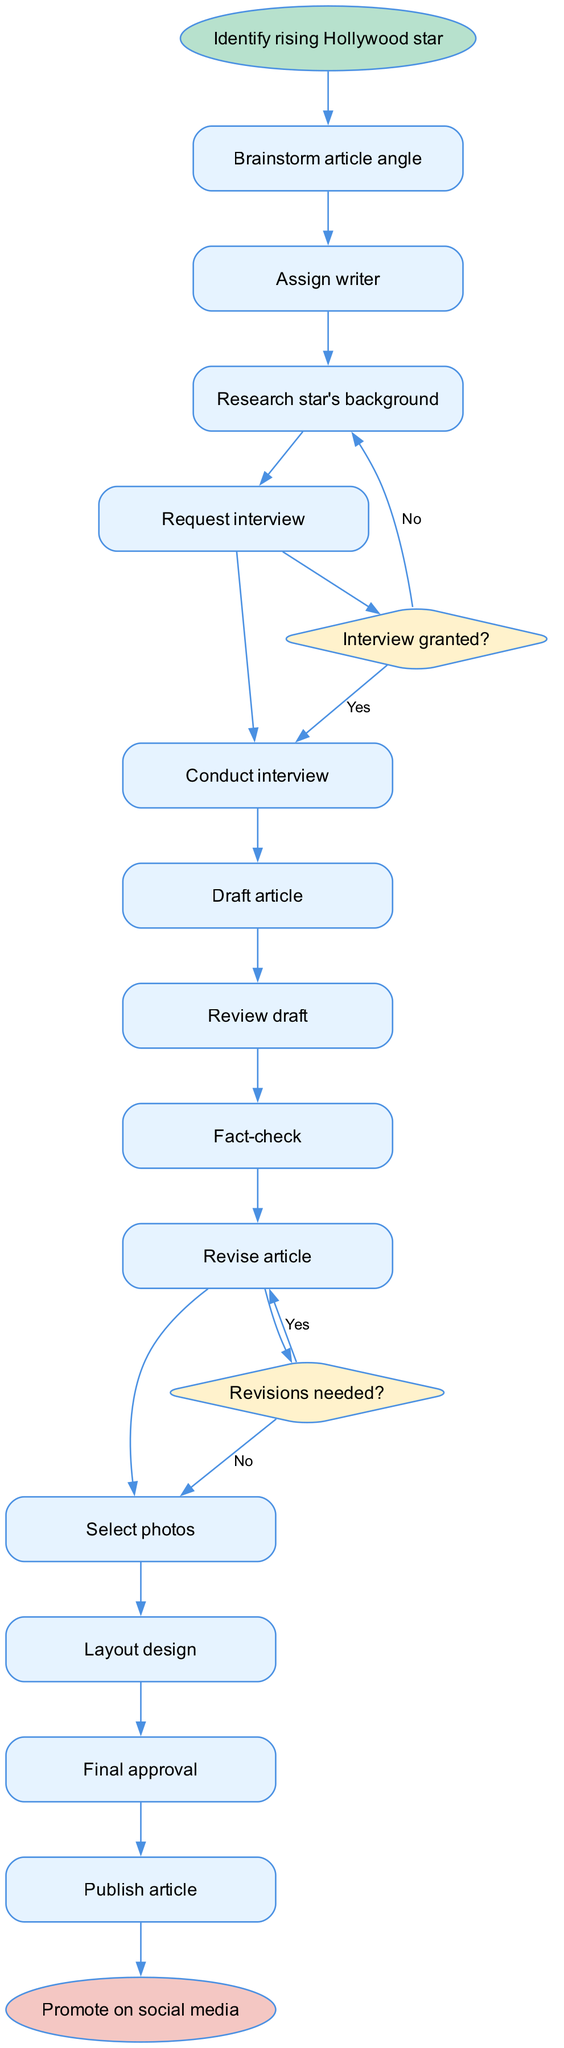What is the starting node of the diagram? The starting node is explicitly stated in the provided data as "Identify rising Hollywood star", which initiates the editorial process represented in the diagram.
Answer: Identify rising Hollywood star How many activities are listed in the diagram? There are 12 activities listed in the data under the "activities" key. Counting each of them provides the answer.
Answer: 12 What is the last activity before publishing the article? The last activity before publishing is "Final approval", which comes immediately before the end node "Promote on social media".
Answer: Final approval What happens if the interview is not granted? If the interview is not granted, the process flows to "Research alternative sources", which is the specified action in the decision block for the question "Interview granted?".
Answer: Research alternative sources How many decision nodes are present in the diagram? The data specifies two decision nodes: one concerning whether the interview is granted and another regarding revisions. Therefore, counting them provides the answer.
Answer: 2 What is the decision made after reviewing the draft? After reviewing the draft, the decision made is "Revisions needed?", leading to either "Revise article" or "Select photos" based on the answer.
Answer: Revisions needed? What is the relationship between "Draft article" and "Review draft"? The "Draft article" activity directly leads to "Review draft", indicating a sequential flow whereby the article must be drafted before it can be reviewed.
Answer: Sequential flow If the answer to "Interview granted?" is yes, which activity follows? If the answer to "Interview granted?" is yes, the next activity is "Conduct interview", indicating that the process continues with the interview stage.
Answer: Conduct interview What is the end node of the process? The end node is explicitly mentioned in the data as "Promote on social media", representing the final step of the editorial process.
Answer: Promote on social media 